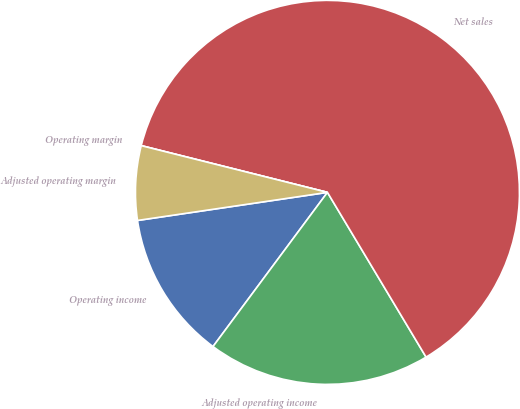<chart> <loc_0><loc_0><loc_500><loc_500><pie_chart><fcel>Operating income<fcel>Adjusted operating income<fcel>Net sales<fcel>Operating margin<fcel>Adjusted operating margin<nl><fcel>12.5%<fcel>18.75%<fcel>62.5%<fcel>0.0%<fcel>6.25%<nl></chart> 